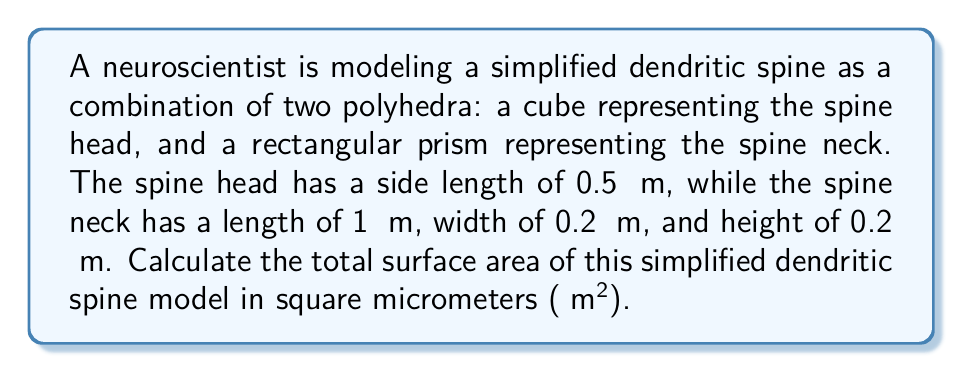Provide a solution to this math problem. Let's approach this problem step-by-step:

1. Calculate the surface area of the spine head (cube):
   - Side length of cube = 0.5 μm
   - Surface area of a cube = 6s², where s is the side length
   - Surface area of spine head = $6 * (0.5 \text{ μm})^2 = 6 * 0.25 \text{ μm}^2 = 1.5 \text{ μm}^2$

2. Calculate the surface area of the spine neck (rectangular prism):
   - Length (l) = 1 μm, width (w) = 0.2 μm, height (h) = 0.2 μm
   - Surface area of a rectangular prism = 2(lw + lh + wh)
   - Surface area of spine neck = $2[(1 * 0.2) + (1 * 0.2) + (0.2 * 0.2)] \text{ μm}^2$
                                 = $2[0.2 + 0.2 + 0.04] \text{ μm}^2$
                                 = $2 * 0.44 \text{ μm}^2 = 0.88 \text{ μm}^2$

3. Calculate the total surface area:
   - Total surface area = Surface area of spine head + Surface area of spine neck
   - Total surface area = $1.5 \text{ μm}^2 + 0.88 \text{ μm}^2 = 2.38 \text{ μm}^2$

Therefore, the total surface area of the simplified dendritic spine model is 2.38 μm².
Answer: 2.38 μm² 